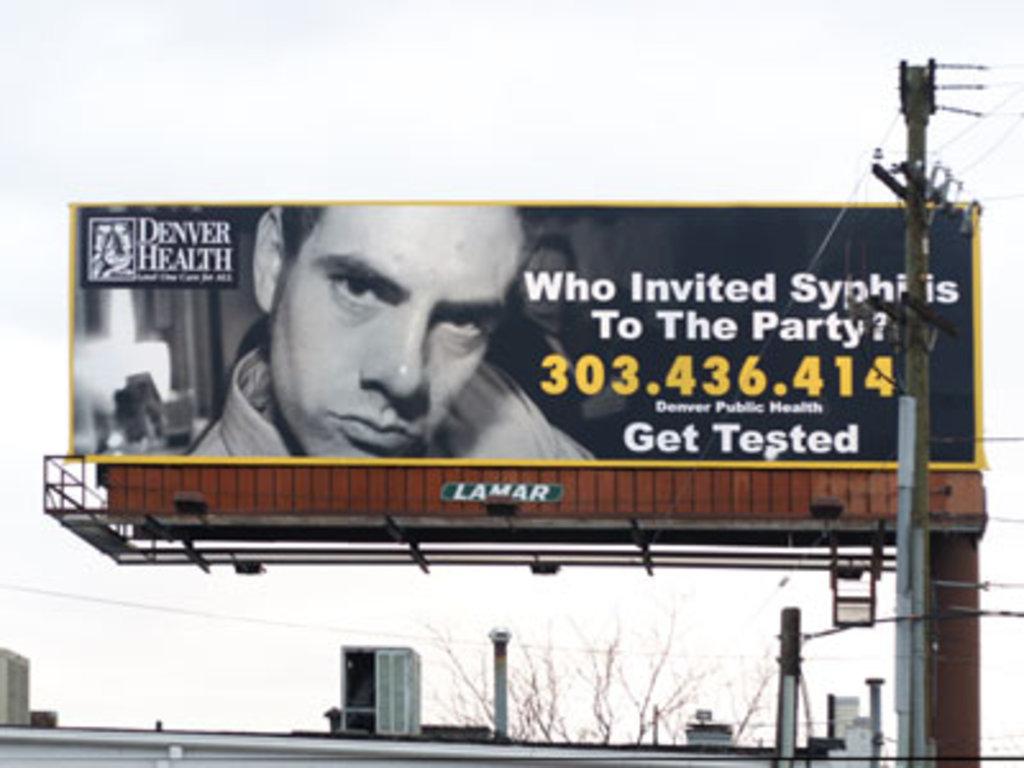What std is the billboard warning about?
Provide a short and direct response. Syphilis. What is the phone number to call for testing?
Keep it short and to the point. 303.436.414. 